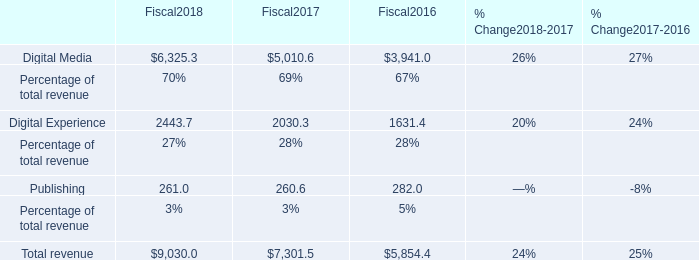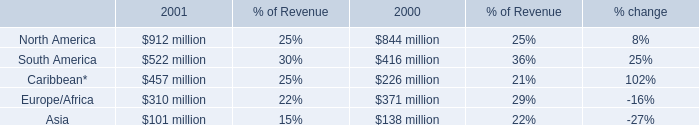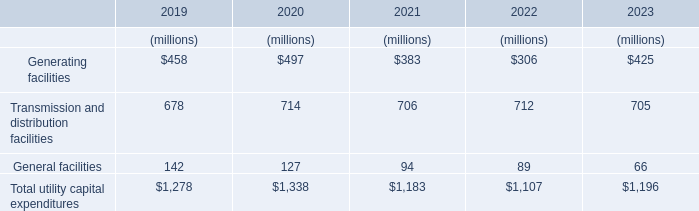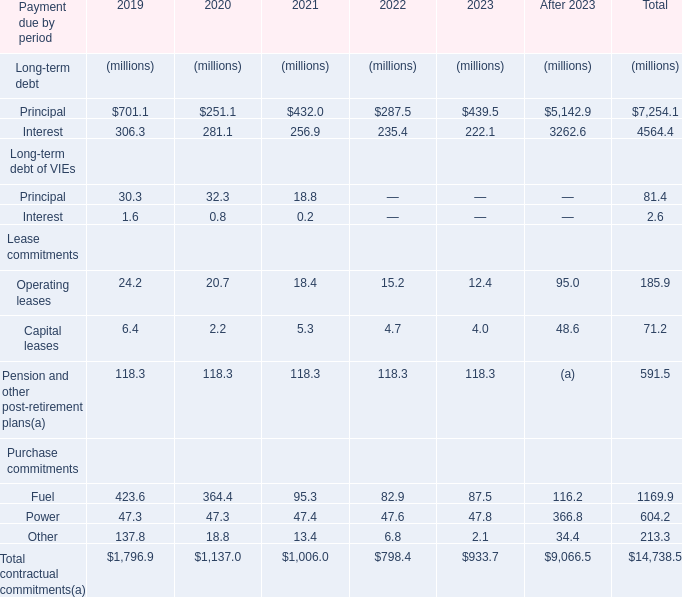What was the average value of Operating leases, Capital leases, Fuel in 2019? (in million) 
Computations: (((24.2 + 6.4) + 423.6) / 3)
Answer: 151.4. 